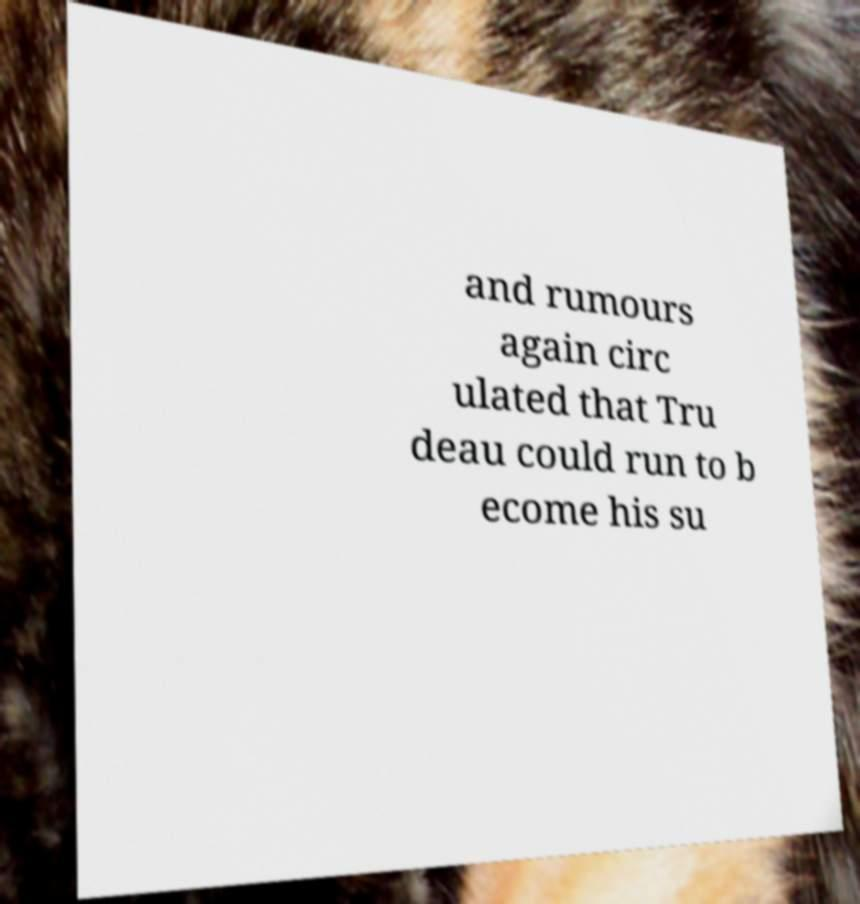There's text embedded in this image that I need extracted. Can you transcribe it verbatim? and rumours again circ ulated that Tru deau could run to b ecome his su 